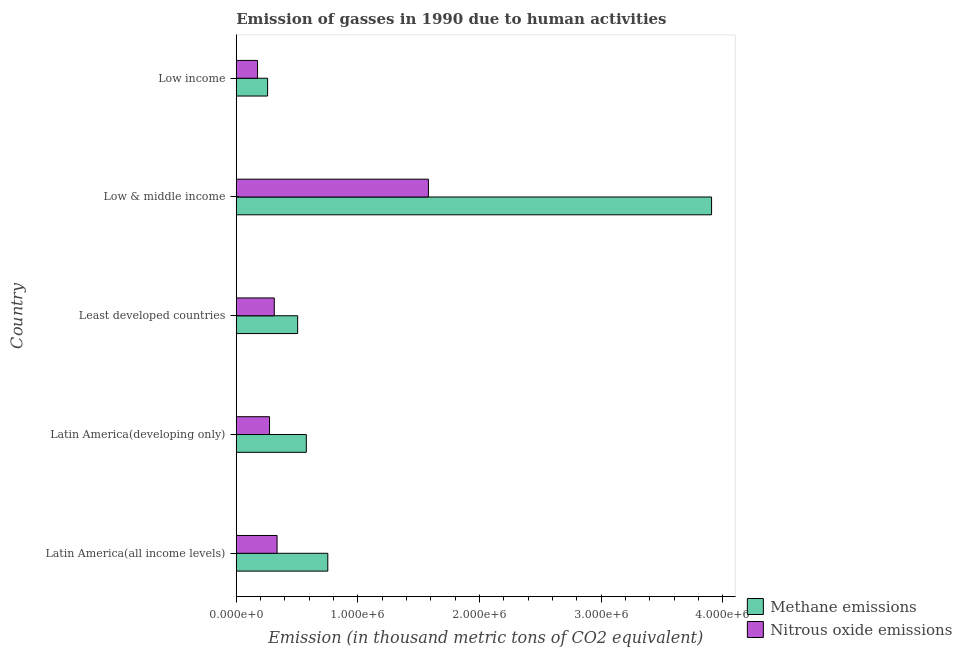How many bars are there on the 5th tick from the bottom?
Your answer should be very brief. 2. What is the label of the 4th group of bars from the top?
Keep it short and to the point. Latin America(developing only). In how many cases, is the number of bars for a given country not equal to the number of legend labels?
Your answer should be very brief. 0. What is the amount of nitrous oxide emissions in Low income?
Your answer should be compact. 1.75e+05. Across all countries, what is the maximum amount of methane emissions?
Keep it short and to the point. 3.91e+06. Across all countries, what is the minimum amount of nitrous oxide emissions?
Make the answer very short. 1.75e+05. In which country was the amount of nitrous oxide emissions minimum?
Offer a terse response. Low income. What is the total amount of methane emissions in the graph?
Provide a short and direct response. 6.00e+06. What is the difference between the amount of methane emissions in Low & middle income and that in Low income?
Provide a short and direct response. 3.65e+06. What is the difference between the amount of methane emissions in Low & middle income and the amount of nitrous oxide emissions in Latin America(developing only)?
Your answer should be very brief. 3.64e+06. What is the average amount of nitrous oxide emissions per country?
Give a very brief answer. 5.35e+05. What is the difference between the amount of nitrous oxide emissions and amount of methane emissions in Low & middle income?
Keep it short and to the point. -2.33e+06. What is the ratio of the amount of methane emissions in Latin America(all income levels) to that in Latin America(developing only)?
Make the answer very short. 1.31. Is the amount of nitrous oxide emissions in Least developed countries less than that in Low income?
Your answer should be very brief. No. What is the difference between the highest and the second highest amount of nitrous oxide emissions?
Provide a short and direct response. 1.24e+06. What is the difference between the highest and the lowest amount of methane emissions?
Give a very brief answer. 3.65e+06. What does the 2nd bar from the top in Least developed countries represents?
Provide a succinct answer. Methane emissions. What does the 1st bar from the bottom in Latin America(developing only) represents?
Your answer should be compact. Methane emissions. How many bars are there?
Offer a terse response. 10. Are all the bars in the graph horizontal?
Your answer should be compact. Yes. What is the difference between two consecutive major ticks on the X-axis?
Your answer should be compact. 1.00e+06. Are the values on the major ticks of X-axis written in scientific E-notation?
Ensure brevity in your answer.  Yes. Does the graph contain any zero values?
Keep it short and to the point. No. How many legend labels are there?
Give a very brief answer. 2. How are the legend labels stacked?
Provide a short and direct response. Vertical. What is the title of the graph?
Ensure brevity in your answer.  Emission of gasses in 1990 due to human activities. What is the label or title of the X-axis?
Offer a terse response. Emission (in thousand metric tons of CO2 equivalent). What is the Emission (in thousand metric tons of CO2 equivalent) in Methane emissions in Latin America(all income levels)?
Your answer should be compact. 7.53e+05. What is the Emission (in thousand metric tons of CO2 equivalent) in Nitrous oxide emissions in Latin America(all income levels)?
Provide a short and direct response. 3.36e+05. What is the Emission (in thousand metric tons of CO2 equivalent) of Methane emissions in Latin America(developing only)?
Your answer should be very brief. 5.76e+05. What is the Emission (in thousand metric tons of CO2 equivalent) in Nitrous oxide emissions in Latin America(developing only)?
Offer a very short reply. 2.74e+05. What is the Emission (in thousand metric tons of CO2 equivalent) of Methane emissions in Least developed countries?
Provide a succinct answer. 5.05e+05. What is the Emission (in thousand metric tons of CO2 equivalent) in Nitrous oxide emissions in Least developed countries?
Ensure brevity in your answer.  3.13e+05. What is the Emission (in thousand metric tons of CO2 equivalent) in Methane emissions in Low & middle income?
Your answer should be very brief. 3.91e+06. What is the Emission (in thousand metric tons of CO2 equivalent) of Nitrous oxide emissions in Low & middle income?
Give a very brief answer. 1.58e+06. What is the Emission (in thousand metric tons of CO2 equivalent) of Methane emissions in Low income?
Provide a succinct answer. 2.58e+05. What is the Emission (in thousand metric tons of CO2 equivalent) of Nitrous oxide emissions in Low income?
Provide a succinct answer. 1.75e+05. Across all countries, what is the maximum Emission (in thousand metric tons of CO2 equivalent) of Methane emissions?
Provide a succinct answer. 3.91e+06. Across all countries, what is the maximum Emission (in thousand metric tons of CO2 equivalent) of Nitrous oxide emissions?
Provide a succinct answer. 1.58e+06. Across all countries, what is the minimum Emission (in thousand metric tons of CO2 equivalent) of Methane emissions?
Offer a very short reply. 2.58e+05. Across all countries, what is the minimum Emission (in thousand metric tons of CO2 equivalent) in Nitrous oxide emissions?
Keep it short and to the point. 1.75e+05. What is the total Emission (in thousand metric tons of CO2 equivalent) of Methane emissions in the graph?
Ensure brevity in your answer.  6.00e+06. What is the total Emission (in thousand metric tons of CO2 equivalent) in Nitrous oxide emissions in the graph?
Ensure brevity in your answer.  2.68e+06. What is the difference between the Emission (in thousand metric tons of CO2 equivalent) in Methane emissions in Latin America(all income levels) and that in Latin America(developing only)?
Provide a short and direct response. 1.77e+05. What is the difference between the Emission (in thousand metric tons of CO2 equivalent) of Nitrous oxide emissions in Latin America(all income levels) and that in Latin America(developing only)?
Your answer should be very brief. 6.18e+04. What is the difference between the Emission (in thousand metric tons of CO2 equivalent) in Methane emissions in Latin America(all income levels) and that in Least developed countries?
Give a very brief answer. 2.48e+05. What is the difference between the Emission (in thousand metric tons of CO2 equivalent) of Nitrous oxide emissions in Latin America(all income levels) and that in Least developed countries?
Provide a succinct answer. 2.29e+04. What is the difference between the Emission (in thousand metric tons of CO2 equivalent) of Methane emissions in Latin America(all income levels) and that in Low & middle income?
Give a very brief answer. -3.16e+06. What is the difference between the Emission (in thousand metric tons of CO2 equivalent) of Nitrous oxide emissions in Latin America(all income levels) and that in Low & middle income?
Provide a succinct answer. -1.24e+06. What is the difference between the Emission (in thousand metric tons of CO2 equivalent) of Methane emissions in Latin America(all income levels) and that in Low income?
Provide a succinct answer. 4.95e+05. What is the difference between the Emission (in thousand metric tons of CO2 equivalent) of Nitrous oxide emissions in Latin America(all income levels) and that in Low income?
Ensure brevity in your answer.  1.61e+05. What is the difference between the Emission (in thousand metric tons of CO2 equivalent) in Methane emissions in Latin America(developing only) and that in Least developed countries?
Provide a short and direct response. 7.12e+04. What is the difference between the Emission (in thousand metric tons of CO2 equivalent) of Nitrous oxide emissions in Latin America(developing only) and that in Least developed countries?
Give a very brief answer. -3.90e+04. What is the difference between the Emission (in thousand metric tons of CO2 equivalent) in Methane emissions in Latin America(developing only) and that in Low & middle income?
Keep it short and to the point. -3.33e+06. What is the difference between the Emission (in thousand metric tons of CO2 equivalent) in Nitrous oxide emissions in Latin America(developing only) and that in Low & middle income?
Ensure brevity in your answer.  -1.31e+06. What is the difference between the Emission (in thousand metric tons of CO2 equivalent) of Methane emissions in Latin America(developing only) and that in Low income?
Keep it short and to the point. 3.18e+05. What is the difference between the Emission (in thousand metric tons of CO2 equivalent) in Nitrous oxide emissions in Latin America(developing only) and that in Low income?
Offer a terse response. 9.87e+04. What is the difference between the Emission (in thousand metric tons of CO2 equivalent) of Methane emissions in Least developed countries and that in Low & middle income?
Your answer should be very brief. -3.40e+06. What is the difference between the Emission (in thousand metric tons of CO2 equivalent) in Nitrous oxide emissions in Least developed countries and that in Low & middle income?
Make the answer very short. -1.27e+06. What is the difference between the Emission (in thousand metric tons of CO2 equivalent) of Methane emissions in Least developed countries and that in Low income?
Ensure brevity in your answer.  2.47e+05. What is the difference between the Emission (in thousand metric tons of CO2 equivalent) of Nitrous oxide emissions in Least developed countries and that in Low income?
Provide a short and direct response. 1.38e+05. What is the difference between the Emission (in thousand metric tons of CO2 equivalent) in Methane emissions in Low & middle income and that in Low income?
Make the answer very short. 3.65e+06. What is the difference between the Emission (in thousand metric tons of CO2 equivalent) of Nitrous oxide emissions in Low & middle income and that in Low income?
Offer a terse response. 1.41e+06. What is the difference between the Emission (in thousand metric tons of CO2 equivalent) in Methane emissions in Latin America(all income levels) and the Emission (in thousand metric tons of CO2 equivalent) in Nitrous oxide emissions in Latin America(developing only)?
Your response must be concise. 4.79e+05. What is the difference between the Emission (in thousand metric tons of CO2 equivalent) in Methane emissions in Latin America(all income levels) and the Emission (in thousand metric tons of CO2 equivalent) in Nitrous oxide emissions in Least developed countries?
Give a very brief answer. 4.40e+05. What is the difference between the Emission (in thousand metric tons of CO2 equivalent) in Methane emissions in Latin America(all income levels) and the Emission (in thousand metric tons of CO2 equivalent) in Nitrous oxide emissions in Low & middle income?
Offer a terse response. -8.27e+05. What is the difference between the Emission (in thousand metric tons of CO2 equivalent) in Methane emissions in Latin America(all income levels) and the Emission (in thousand metric tons of CO2 equivalent) in Nitrous oxide emissions in Low income?
Your answer should be compact. 5.78e+05. What is the difference between the Emission (in thousand metric tons of CO2 equivalent) of Methane emissions in Latin America(developing only) and the Emission (in thousand metric tons of CO2 equivalent) of Nitrous oxide emissions in Least developed countries?
Provide a succinct answer. 2.63e+05. What is the difference between the Emission (in thousand metric tons of CO2 equivalent) of Methane emissions in Latin America(developing only) and the Emission (in thousand metric tons of CO2 equivalent) of Nitrous oxide emissions in Low & middle income?
Your response must be concise. -1.00e+06. What is the difference between the Emission (in thousand metric tons of CO2 equivalent) in Methane emissions in Latin America(developing only) and the Emission (in thousand metric tons of CO2 equivalent) in Nitrous oxide emissions in Low income?
Offer a terse response. 4.01e+05. What is the difference between the Emission (in thousand metric tons of CO2 equivalent) in Methane emissions in Least developed countries and the Emission (in thousand metric tons of CO2 equivalent) in Nitrous oxide emissions in Low & middle income?
Ensure brevity in your answer.  -1.08e+06. What is the difference between the Emission (in thousand metric tons of CO2 equivalent) in Methane emissions in Least developed countries and the Emission (in thousand metric tons of CO2 equivalent) in Nitrous oxide emissions in Low income?
Your response must be concise. 3.30e+05. What is the difference between the Emission (in thousand metric tons of CO2 equivalent) of Methane emissions in Low & middle income and the Emission (in thousand metric tons of CO2 equivalent) of Nitrous oxide emissions in Low income?
Your response must be concise. 3.73e+06. What is the average Emission (in thousand metric tons of CO2 equivalent) of Methane emissions per country?
Your response must be concise. 1.20e+06. What is the average Emission (in thousand metric tons of CO2 equivalent) in Nitrous oxide emissions per country?
Provide a short and direct response. 5.35e+05. What is the difference between the Emission (in thousand metric tons of CO2 equivalent) in Methane emissions and Emission (in thousand metric tons of CO2 equivalent) in Nitrous oxide emissions in Latin America(all income levels)?
Offer a very short reply. 4.17e+05. What is the difference between the Emission (in thousand metric tons of CO2 equivalent) in Methane emissions and Emission (in thousand metric tons of CO2 equivalent) in Nitrous oxide emissions in Latin America(developing only)?
Ensure brevity in your answer.  3.02e+05. What is the difference between the Emission (in thousand metric tons of CO2 equivalent) of Methane emissions and Emission (in thousand metric tons of CO2 equivalent) of Nitrous oxide emissions in Least developed countries?
Offer a terse response. 1.92e+05. What is the difference between the Emission (in thousand metric tons of CO2 equivalent) of Methane emissions and Emission (in thousand metric tons of CO2 equivalent) of Nitrous oxide emissions in Low & middle income?
Your answer should be very brief. 2.33e+06. What is the difference between the Emission (in thousand metric tons of CO2 equivalent) of Methane emissions and Emission (in thousand metric tons of CO2 equivalent) of Nitrous oxide emissions in Low income?
Your answer should be compact. 8.29e+04. What is the ratio of the Emission (in thousand metric tons of CO2 equivalent) of Methane emissions in Latin America(all income levels) to that in Latin America(developing only)?
Your answer should be very brief. 1.31. What is the ratio of the Emission (in thousand metric tons of CO2 equivalent) of Nitrous oxide emissions in Latin America(all income levels) to that in Latin America(developing only)?
Make the answer very short. 1.23. What is the ratio of the Emission (in thousand metric tons of CO2 equivalent) in Methane emissions in Latin America(all income levels) to that in Least developed countries?
Offer a very short reply. 1.49. What is the ratio of the Emission (in thousand metric tons of CO2 equivalent) of Nitrous oxide emissions in Latin America(all income levels) to that in Least developed countries?
Provide a succinct answer. 1.07. What is the ratio of the Emission (in thousand metric tons of CO2 equivalent) of Methane emissions in Latin America(all income levels) to that in Low & middle income?
Give a very brief answer. 0.19. What is the ratio of the Emission (in thousand metric tons of CO2 equivalent) of Nitrous oxide emissions in Latin America(all income levels) to that in Low & middle income?
Keep it short and to the point. 0.21. What is the ratio of the Emission (in thousand metric tons of CO2 equivalent) in Methane emissions in Latin America(all income levels) to that in Low income?
Your response must be concise. 2.92. What is the ratio of the Emission (in thousand metric tons of CO2 equivalent) of Nitrous oxide emissions in Latin America(all income levels) to that in Low income?
Give a very brief answer. 1.92. What is the ratio of the Emission (in thousand metric tons of CO2 equivalent) of Methane emissions in Latin America(developing only) to that in Least developed countries?
Your response must be concise. 1.14. What is the ratio of the Emission (in thousand metric tons of CO2 equivalent) of Nitrous oxide emissions in Latin America(developing only) to that in Least developed countries?
Your answer should be very brief. 0.88. What is the ratio of the Emission (in thousand metric tons of CO2 equivalent) of Methane emissions in Latin America(developing only) to that in Low & middle income?
Keep it short and to the point. 0.15. What is the ratio of the Emission (in thousand metric tons of CO2 equivalent) in Nitrous oxide emissions in Latin America(developing only) to that in Low & middle income?
Keep it short and to the point. 0.17. What is the ratio of the Emission (in thousand metric tons of CO2 equivalent) in Methane emissions in Latin America(developing only) to that in Low income?
Your answer should be compact. 2.23. What is the ratio of the Emission (in thousand metric tons of CO2 equivalent) of Nitrous oxide emissions in Latin America(developing only) to that in Low income?
Offer a terse response. 1.56. What is the ratio of the Emission (in thousand metric tons of CO2 equivalent) of Methane emissions in Least developed countries to that in Low & middle income?
Your response must be concise. 0.13. What is the ratio of the Emission (in thousand metric tons of CO2 equivalent) of Nitrous oxide emissions in Least developed countries to that in Low & middle income?
Provide a succinct answer. 0.2. What is the ratio of the Emission (in thousand metric tons of CO2 equivalent) of Methane emissions in Least developed countries to that in Low income?
Make the answer very short. 1.96. What is the ratio of the Emission (in thousand metric tons of CO2 equivalent) in Nitrous oxide emissions in Least developed countries to that in Low income?
Ensure brevity in your answer.  1.79. What is the ratio of the Emission (in thousand metric tons of CO2 equivalent) of Methane emissions in Low & middle income to that in Low income?
Your answer should be very brief. 15.16. What is the ratio of the Emission (in thousand metric tons of CO2 equivalent) in Nitrous oxide emissions in Low & middle income to that in Low income?
Provide a succinct answer. 9.03. What is the difference between the highest and the second highest Emission (in thousand metric tons of CO2 equivalent) in Methane emissions?
Your response must be concise. 3.16e+06. What is the difference between the highest and the second highest Emission (in thousand metric tons of CO2 equivalent) of Nitrous oxide emissions?
Provide a succinct answer. 1.24e+06. What is the difference between the highest and the lowest Emission (in thousand metric tons of CO2 equivalent) in Methane emissions?
Provide a succinct answer. 3.65e+06. What is the difference between the highest and the lowest Emission (in thousand metric tons of CO2 equivalent) of Nitrous oxide emissions?
Your answer should be very brief. 1.41e+06. 